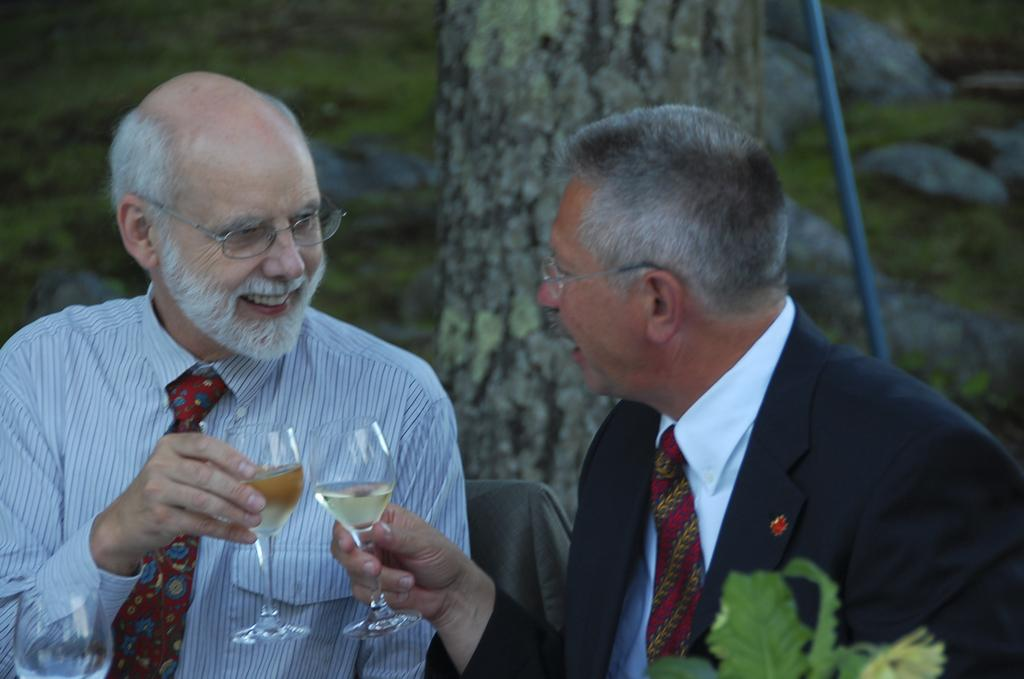How many people are in the image? There are two men in the image. What are the men holding in their hands? The men are holding glasses in their hands. What can be seen in the background of the image? There is a tree, a plant, and a rod in the background of the image. What type of wine is being served in the glasses in the image? There is no indication of wine being served in the image; the men are holding glasses, but the contents are not specified. 